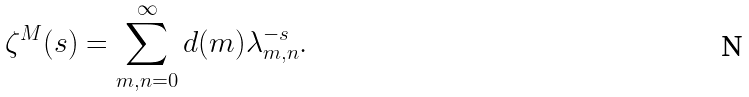<formula> <loc_0><loc_0><loc_500><loc_500>\zeta ^ { M } ( s ) = \sum _ { m , n = 0 } ^ { \infty } d ( m ) \lambda _ { m , n } ^ { - s } .</formula> 